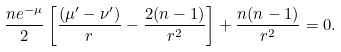Convert formula to latex. <formula><loc_0><loc_0><loc_500><loc_500>\frac { n e ^ { - \mu } } { 2 } \left [ \frac { ( \mu ^ { \prime } - \nu ^ { \prime } ) } { r } - \frac { 2 ( n - 1 ) } { r ^ { 2 } } \right ] + \frac { n ( n - 1 ) } { r ^ { 2 } } = 0 .</formula> 